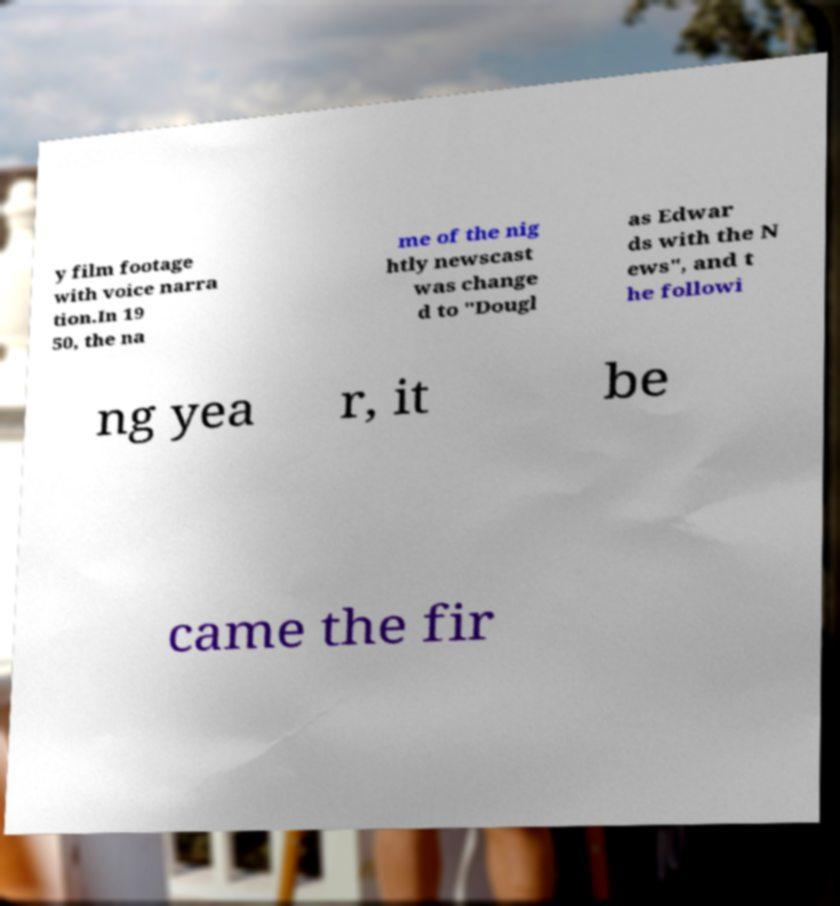Can you accurately transcribe the text from the provided image for me? y film footage with voice narra tion.In 19 50, the na me of the nig htly newscast was change d to "Dougl as Edwar ds with the N ews", and t he followi ng yea r, it be came the fir 